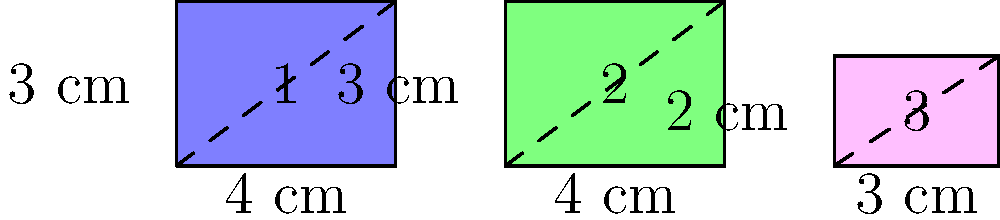Look at these colorful hamster wheels! Which two wheels are the same size and shape? Remember, wheels that are the same size and shape are called congruent. Let's look at each hamster wheel carefully:

1. The blue wheel (1):
   - It's a rectangle
   - Width = 4 cm
   - Height = 3 cm

2. The green wheel (2):
   - It's also a rectangle
   - Width = 4 cm
   - Height = 3 cm

3. The pink wheel (3):
   - It's a rectangle too
   - Width = 3 cm
   - Height = 2 cm

To be congruent, shapes must have the same size and shape. 

Comparing the wheels:
- Wheels 1 and 2 have the same width (4 cm) and height (3 cm)
- Wheel 3 has different measurements from the others

Therefore, wheels 1 and 2 are congruent because they have the same size and shape.
Answer: Wheels 1 and 2 